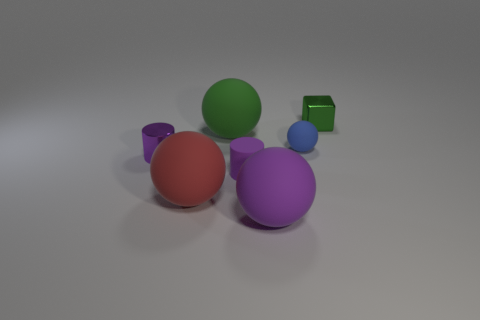Add 1 purple matte balls. How many objects exist? 8 Subtract all spheres. How many objects are left? 3 Subtract 1 green blocks. How many objects are left? 6 Subtract all small purple things. Subtract all yellow objects. How many objects are left? 5 Add 6 green things. How many green things are left? 8 Add 5 purple balls. How many purple balls exist? 6 